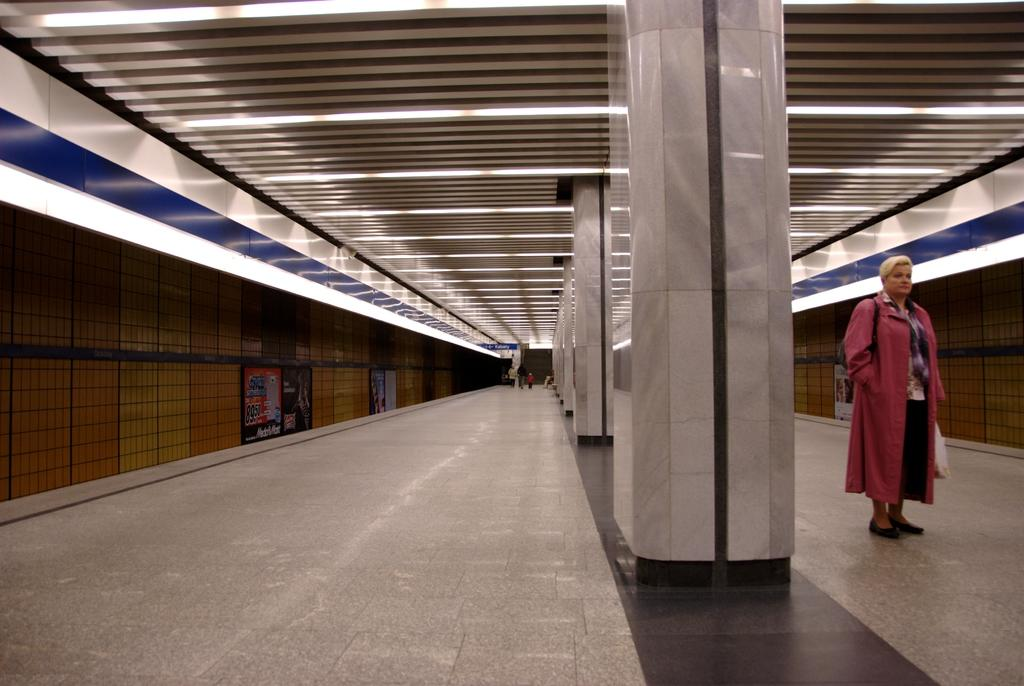What are the people in the image doing? The people in the image are walking on a path. What can be seen on the roof in the image? There are lights on the roof in the image. What type of barrier is present in the image? There is fencing in the image. What architectural feature can be seen in the image? There is a pillar in the image. What type of juice is being served at the nation's celebration in the image? There is no juice or nation's celebration present in the image; it features people walking on a path with lights, fencing, and a pillar. What type of stem is growing from the ground in the image? There is no stem growing from the ground in the image. 